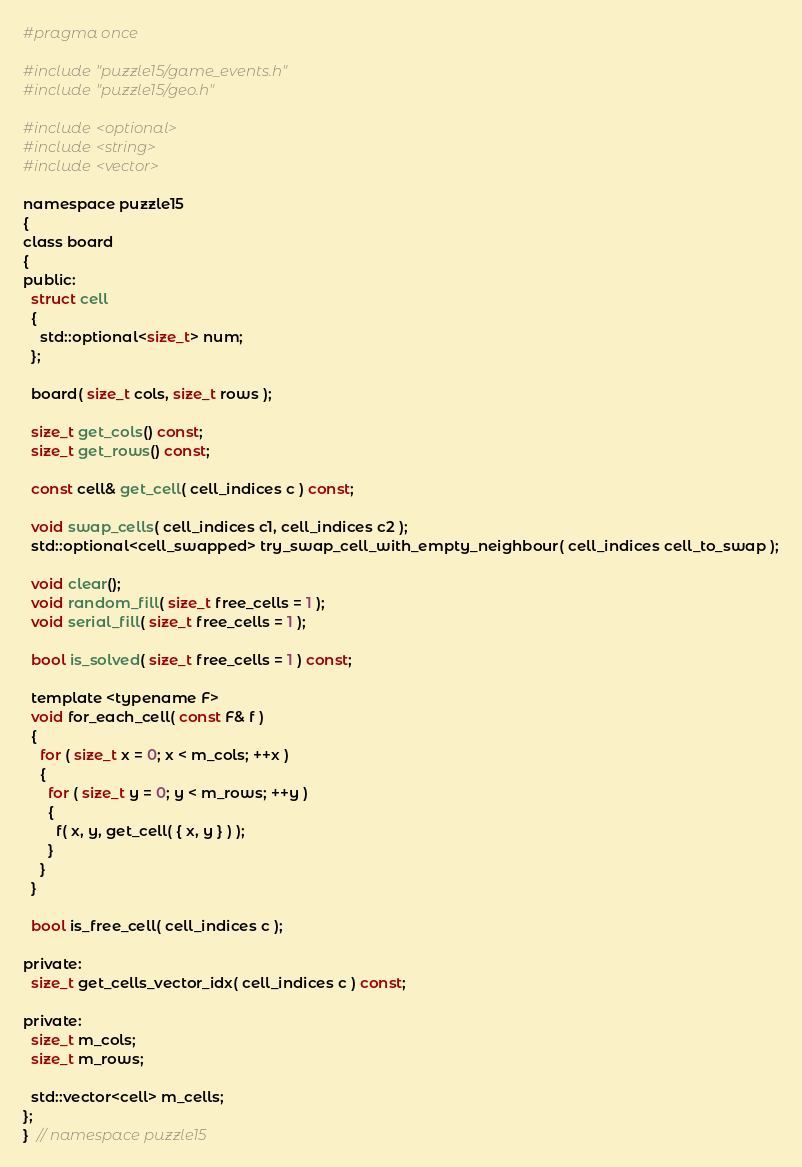Convert code to text. <code><loc_0><loc_0><loc_500><loc_500><_C_>#pragma once

#include "puzzle15/game_events.h"
#include "puzzle15/geo.h"

#include <optional>
#include <string>
#include <vector>

namespace puzzle15
{
class board
{
public:
  struct cell
  {
    std::optional<size_t> num;
  };

  board( size_t cols, size_t rows );

  size_t get_cols() const;
  size_t get_rows() const;

  const cell& get_cell( cell_indices c ) const;

  void swap_cells( cell_indices c1, cell_indices c2 );
  std::optional<cell_swapped> try_swap_cell_with_empty_neighbour( cell_indices cell_to_swap );

  void clear();
  void random_fill( size_t free_cells = 1 );
  void serial_fill( size_t free_cells = 1 );

  bool is_solved( size_t free_cells = 1 ) const;

  template <typename F>
  void for_each_cell( const F& f )
  {
    for ( size_t x = 0; x < m_cols; ++x )
    {
      for ( size_t y = 0; y < m_rows; ++y )
      {
        f( x, y, get_cell( { x, y } ) );
      }
    }
  }

  bool is_free_cell( cell_indices c );

private:
  size_t get_cells_vector_idx( cell_indices c ) const;

private:
  size_t m_cols;
  size_t m_rows;

  std::vector<cell> m_cells;
};
}  // namespace puzzle15</code> 